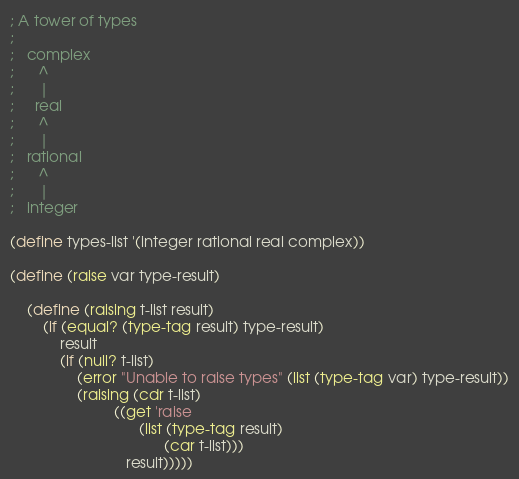<code> <loc_0><loc_0><loc_500><loc_500><_Scheme_>; A tower of types
;
;   complex
;      ^
;      |
;     real
;      ^
;      |
;   rational
;      ^
;      |
;   integer

(define types-list '(integer rational real complex))

(define (raise var type-result)
    
    (define (raising t-list result)
        (if (equal? (type-tag result) type-result)
            result
            (if (null? t-list)
                (error "Unable to raise types" (list (type-tag var) type-result))
                (raising (cdr t-list)
                         ((get 'raise
                               (list (type-tag result) 
                                     (car t-list)))
                            result)))))
</code> 